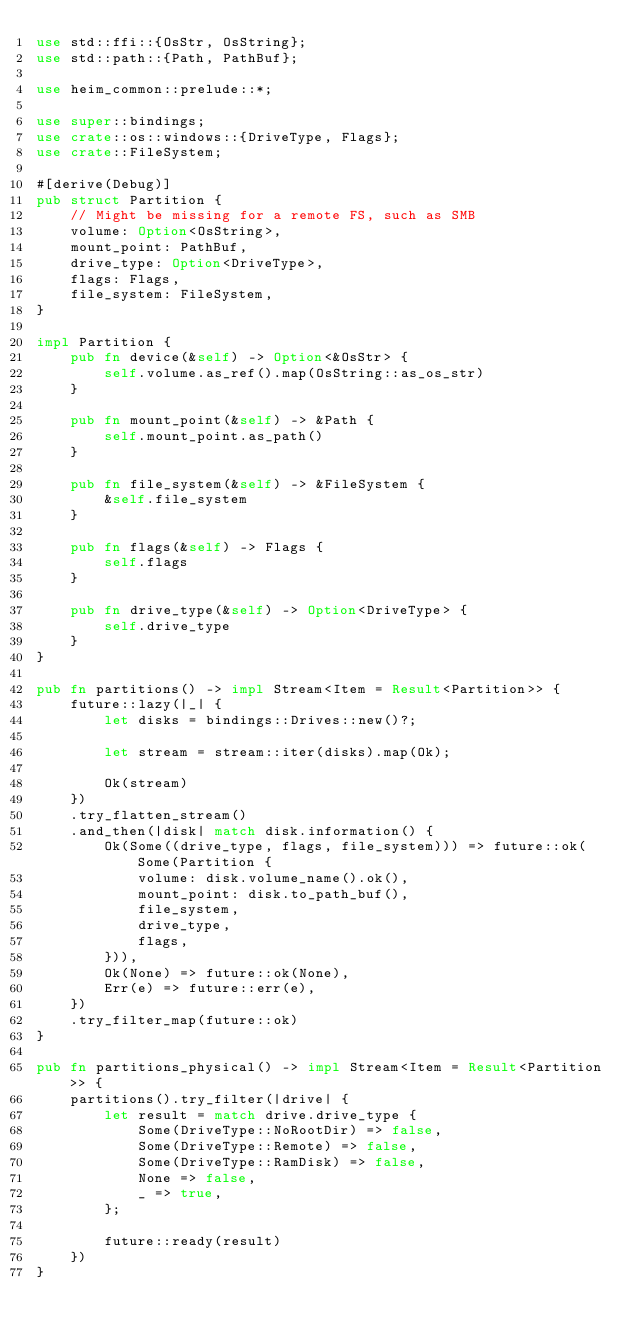Convert code to text. <code><loc_0><loc_0><loc_500><loc_500><_Rust_>use std::ffi::{OsStr, OsString};
use std::path::{Path, PathBuf};

use heim_common::prelude::*;

use super::bindings;
use crate::os::windows::{DriveType, Flags};
use crate::FileSystem;

#[derive(Debug)]
pub struct Partition {
    // Might be missing for a remote FS, such as SMB
    volume: Option<OsString>,
    mount_point: PathBuf,
    drive_type: Option<DriveType>,
    flags: Flags,
    file_system: FileSystem,
}

impl Partition {
    pub fn device(&self) -> Option<&OsStr> {
        self.volume.as_ref().map(OsString::as_os_str)
    }

    pub fn mount_point(&self) -> &Path {
        self.mount_point.as_path()
    }

    pub fn file_system(&self) -> &FileSystem {
        &self.file_system
    }

    pub fn flags(&self) -> Flags {
        self.flags
    }

    pub fn drive_type(&self) -> Option<DriveType> {
        self.drive_type
    }
}

pub fn partitions() -> impl Stream<Item = Result<Partition>> {
    future::lazy(|_| {
        let disks = bindings::Drives::new()?;

        let stream = stream::iter(disks).map(Ok);

        Ok(stream)
    })
    .try_flatten_stream()
    .and_then(|disk| match disk.information() {
        Ok(Some((drive_type, flags, file_system))) => future::ok(Some(Partition {
            volume: disk.volume_name().ok(),
            mount_point: disk.to_path_buf(),
            file_system,
            drive_type,
            flags,
        })),
        Ok(None) => future::ok(None),
        Err(e) => future::err(e),
    })
    .try_filter_map(future::ok)
}

pub fn partitions_physical() -> impl Stream<Item = Result<Partition>> {
    partitions().try_filter(|drive| {
        let result = match drive.drive_type {
            Some(DriveType::NoRootDir) => false,
            Some(DriveType::Remote) => false,
            Some(DriveType::RamDisk) => false,
            None => false,
            _ => true,
        };

        future::ready(result)
    })
}
</code> 